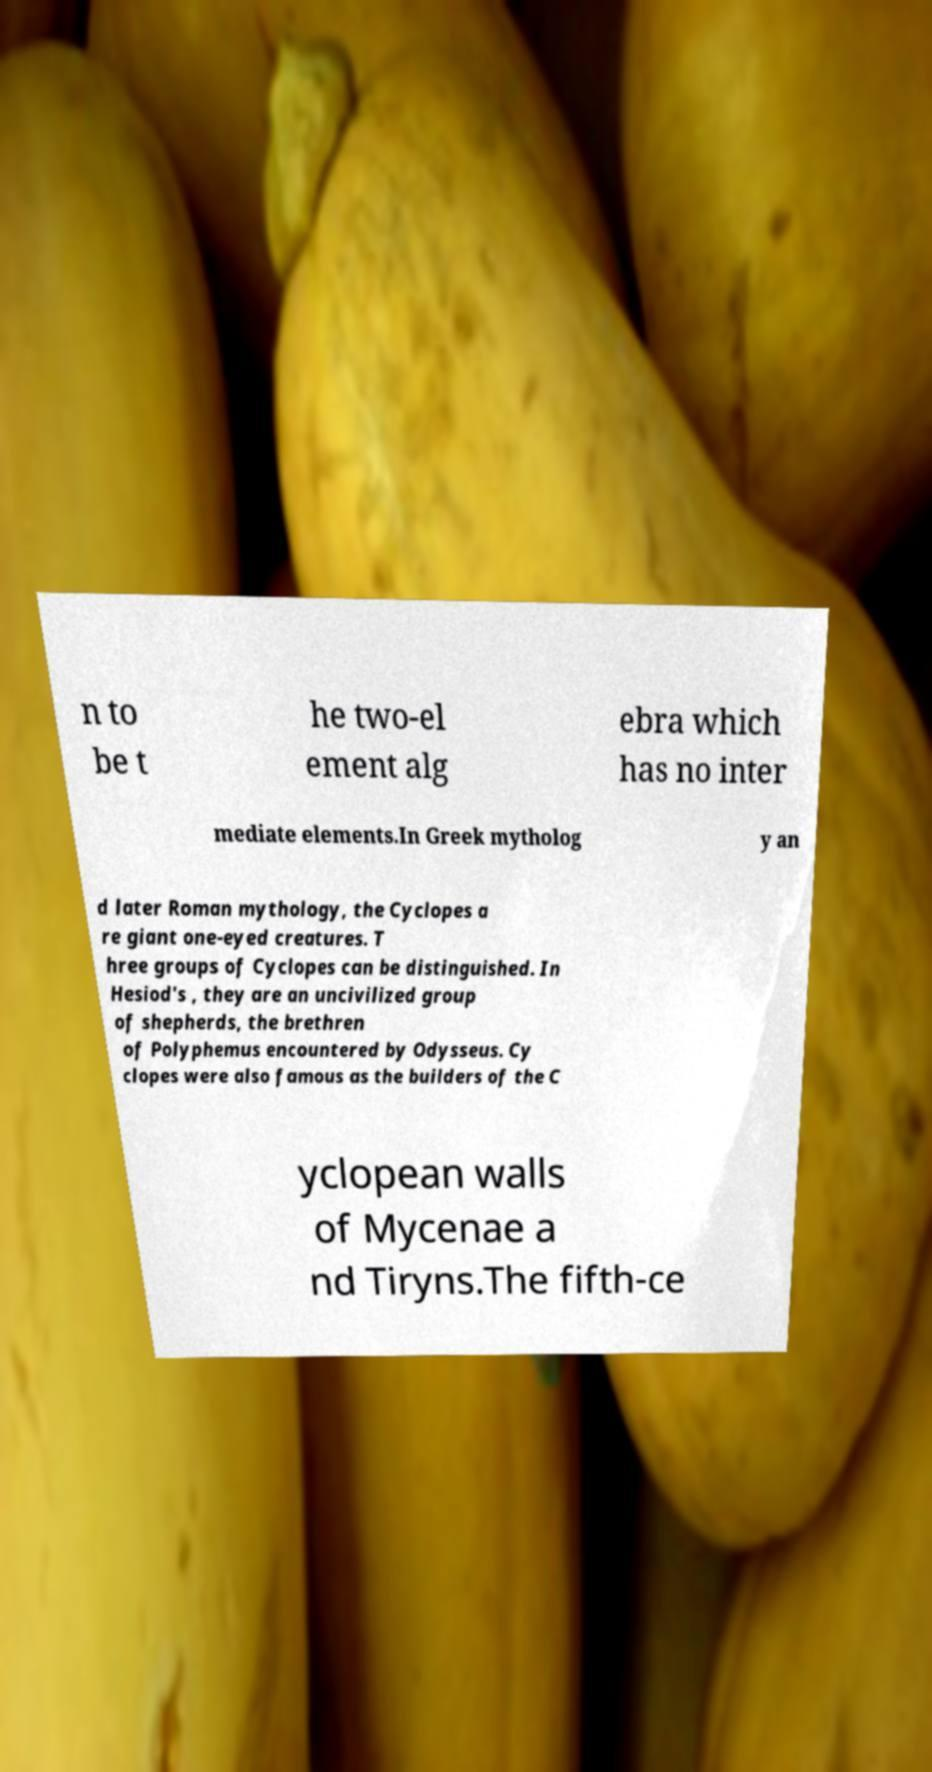Could you extract and type out the text from this image? n to be t he two-el ement alg ebra which has no inter mediate elements.In Greek mytholog y an d later Roman mythology, the Cyclopes a re giant one-eyed creatures. T hree groups of Cyclopes can be distinguished. In Hesiod's , they are an uncivilized group of shepherds, the brethren of Polyphemus encountered by Odysseus. Cy clopes were also famous as the builders of the C yclopean walls of Mycenae a nd Tiryns.The fifth-ce 